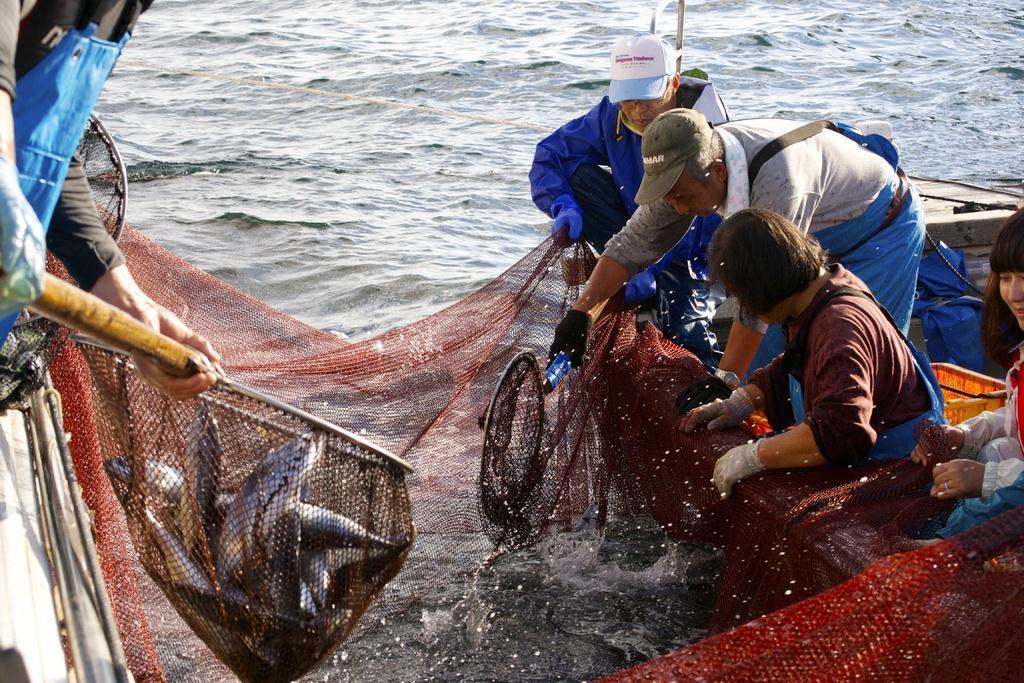Describe this image in one or two sentences. In this image we can see the sea, two boats on the sea truncated, some objects on the boat on the bottom right side of the image, one red color net, two persons holding fishing nets with handles, one woman sitting on the boat, one man in blue dress sitting on the boat, one person in kneeling position, one man bending, one person truncated on the left side of the image and some fishes in the net on the left side of the image. 